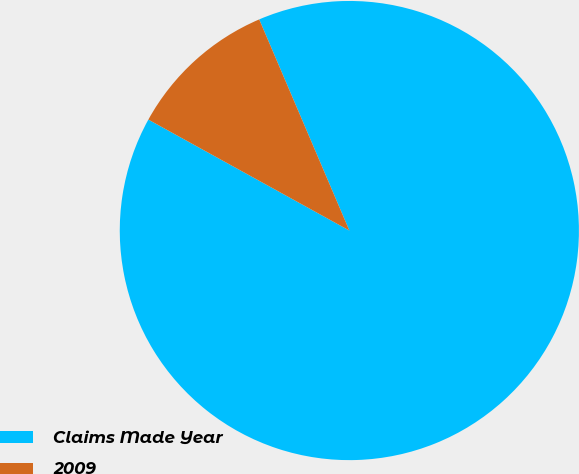Convert chart to OTSL. <chart><loc_0><loc_0><loc_500><loc_500><pie_chart><fcel>Claims Made Year<fcel>2009<nl><fcel>89.45%<fcel>10.55%<nl></chart> 